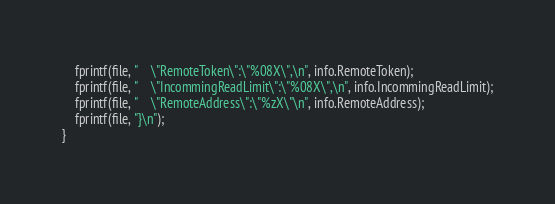Convert code to text. <code><loc_0><loc_0><loc_500><loc_500><_C++_>    fprintf(file, "    \"RemoteToken\":\"%08X\",\n", info.RemoteToken);
    fprintf(file, "    \"IncommingReadLimit\":\"%08X\",\n", info.IncommingReadLimit);
    fprintf(file, "    \"RemoteAddress\":\"%zX\"\n", info.RemoteAddress);
    fprintf(file, "}\n");
}
</code> 